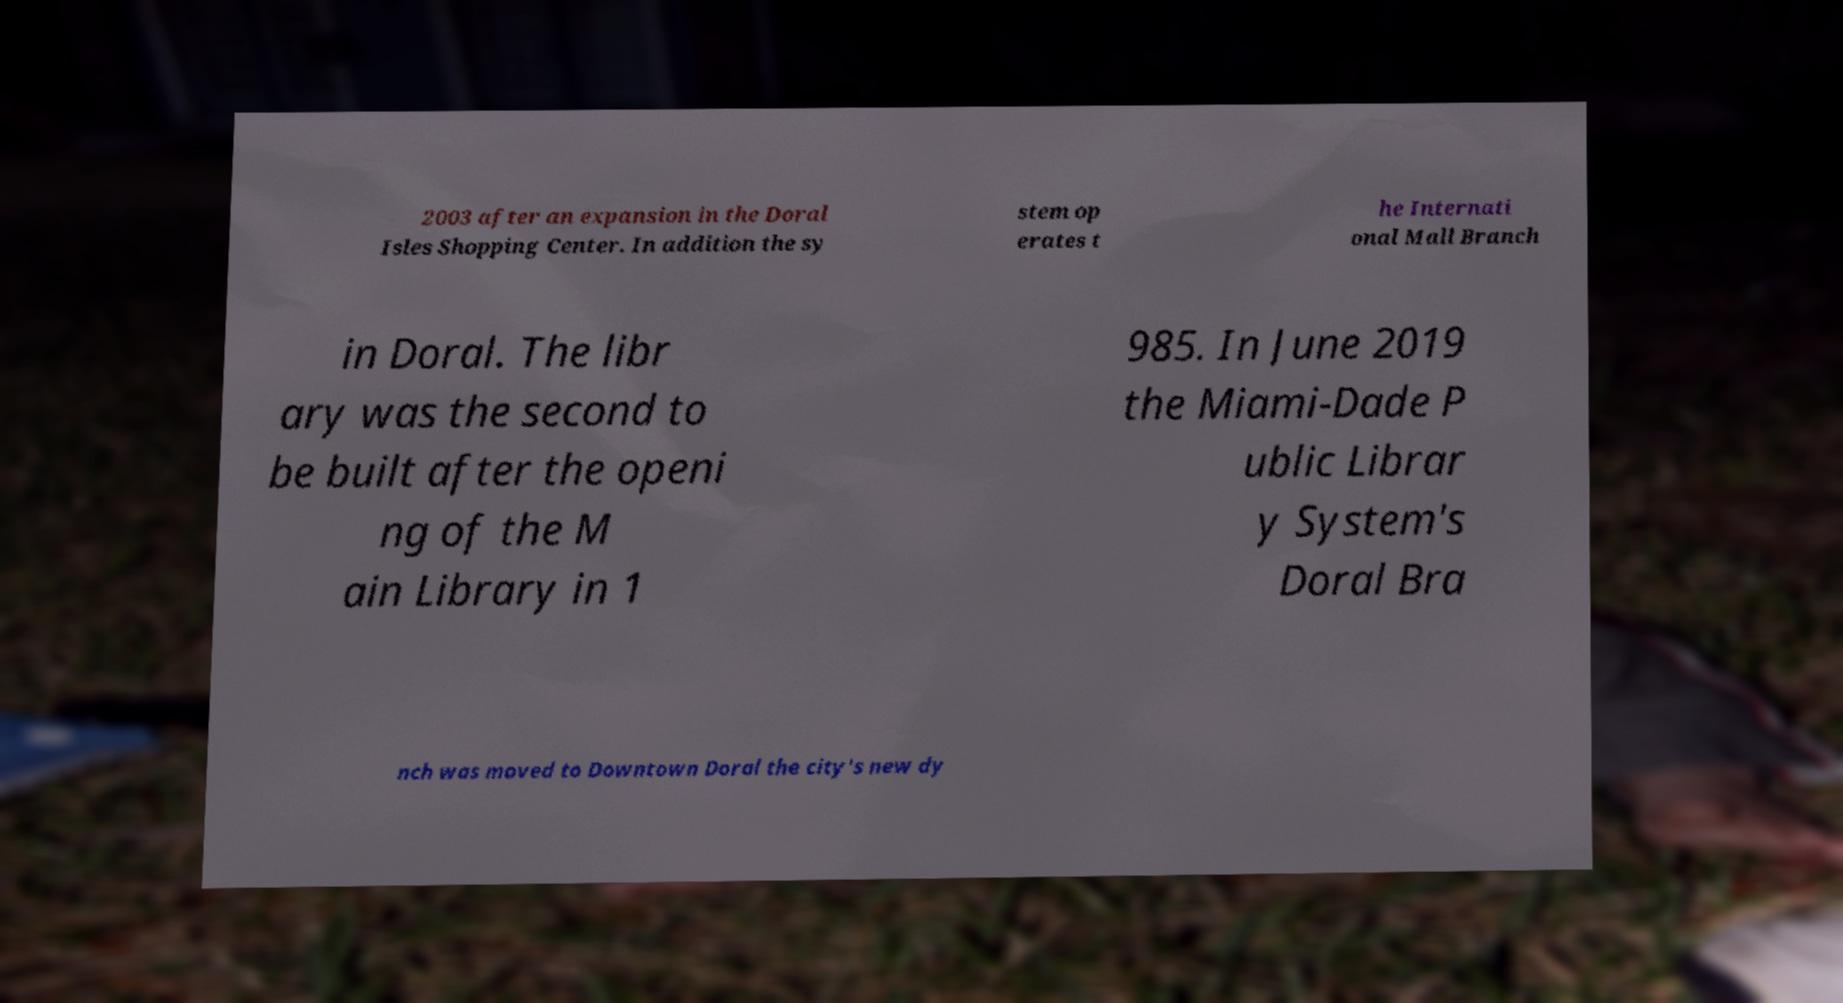Could you assist in decoding the text presented in this image and type it out clearly? 2003 after an expansion in the Doral Isles Shopping Center. In addition the sy stem op erates t he Internati onal Mall Branch in Doral. The libr ary was the second to be built after the openi ng of the M ain Library in 1 985. In June 2019 the Miami-Dade P ublic Librar y System's Doral Bra nch was moved to Downtown Doral the city's new dy 